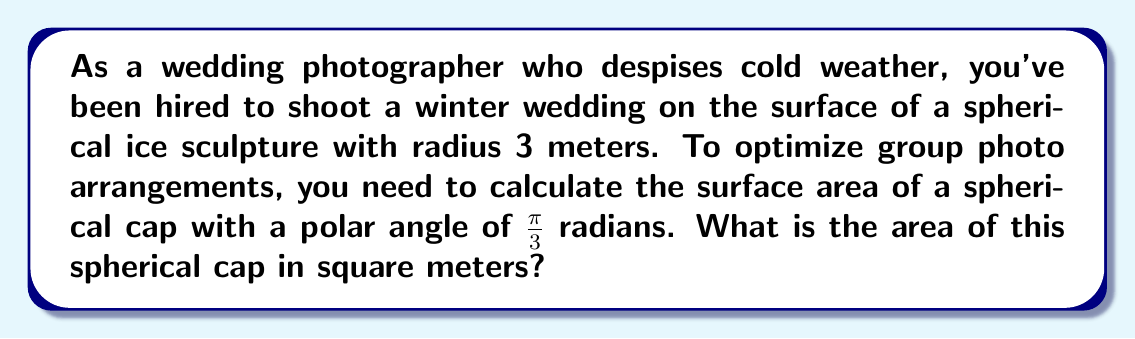Give your solution to this math problem. Let's approach this step-by-step:

1) The formula for the surface area of a spherical cap is:

   $$A = 2\pi r h$$

   where $r$ is the radius of the sphere and $h$ is the height of the cap.

2) We're given the radius $r = 3$ meters and the polar angle $\theta = \frac{\pi}{3}$ radians.

3) To find $h$, we can use the formula:

   $$h = r(1 - \cos\theta)$$

4) Substituting our values:

   $$h = 3(1 - \cos\frac{\pi}{3})$$

5) We know that $\cos\frac{\pi}{3} = \frac{1}{2}$, so:

   $$h = 3(1 - \frac{1}{2}) = 3 \cdot \frac{1}{2} = 1.5$$

6) Now we can substitute this into our surface area formula:

   $$A = 2\pi r h = 2\pi \cdot 3 \cdot 1.5$$

7) Simplifying:

   $$A = 9\pi$$

Therefore, the surface area of the spherical cap is $9\pi$ square meters.
Answer: $9\pi$ m² 